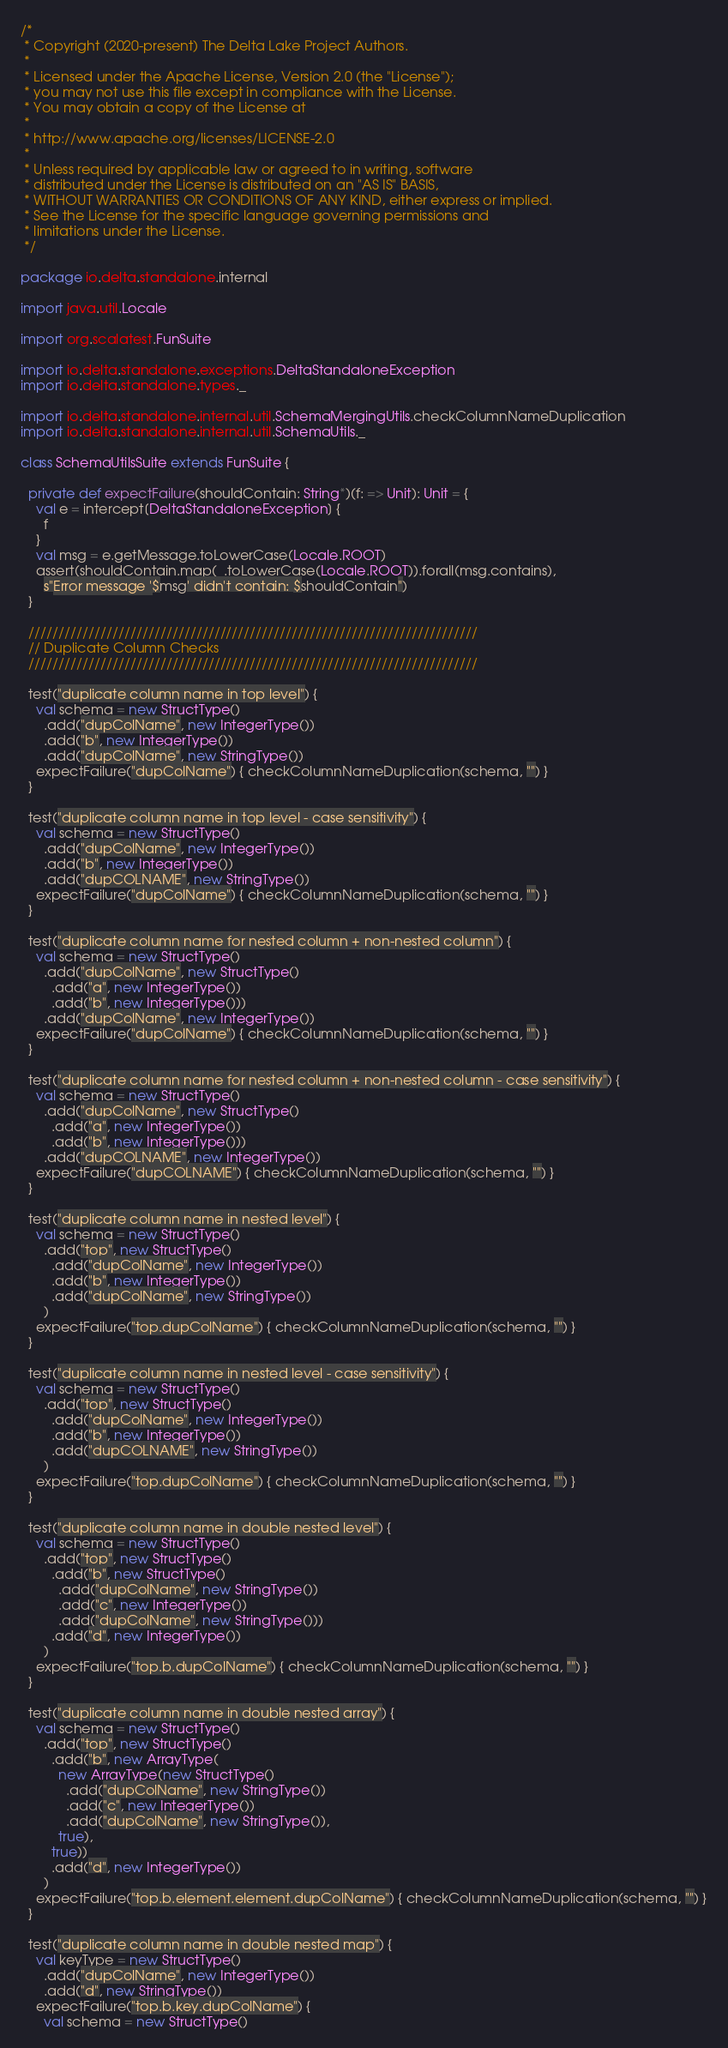<code> <loc_0><loc_0><loc_500><loc_500><_Scala_>/*
 * Copyright (2020-present) The Delta Lake Project Authors.
 *
 * Licensed under the Apache License, Version 2.0 (the "License");
 * you may not use this file except in compliance with the License.
 * You may obtain a copy of the License at
 *
 * http://www.apache.org/licenses/LICENSE-2.0
 *
 * Unless required by applicable law or agreed to in writing, software
 * distributed under the License is distributed on an "AS IS" BASIS,
 * WITHOUT WARRANTIES OR CONDITIONS OF ANY KIND, either express or implied.
 * See the License for the specific language governing permissions and
 * limitations under the License.
 */

package io.delta.standalone.internal

import java.util.Locale

import org.scalatest.FunSuite

import io.delta.standalone.exceptions.DeltaStandaloneException
import io.delta.standalone.types._

import io.delta.standalone.internal.util.SchemaMergingUtils.checkColumnNameDuplication
import io.delta.standalone.internal.util.SchemaUtils._

class SchemaUtilsSuite extends FunSuite {

  private def expectFailure(shouldContain: String*)(f: => Unit): Unit = {
    val e = intercept[DeltaStandaloneException] {
      f
    }
    val msg = e.getMessage.toLowerCase(Locale.ROOT)
    assert(shouldContain.map(_.toLowerCase(Locale.ROOT)).forall(msg.contains),
      s"Error message '$msg' didn't contain: $shouldContain")
  }

  ///////////////////////////////////////////////////////////////////////////
  // Duplicate Column Checks
  ///////////////////////////////////////////////////////////////////////////

  test("duplicate column name in top level") {
    val schema = new StructType()
      .add("dupColName", new IntegerType())
      .add("b", new IntegerType())
      .add("dupColName", new StringType())
    expectFailure("dupColName") { checkColumnNameDuplication(schema, "") }
  }

  test("duplicate column name in top level - case sensitivity") {
    val schema = new StructType()
      .add("dupColName", new IntegerType())
      .add("b", new IntegerType())
      .add("dupCOLNAME", new StringType())
    expectFailure("dupColName") { checkColumnNameDuplication(schema, "") }
  }

  test("duplicate column name for nested column + non-nested column") {
    val schema = new StructType()
      .add("dupColName", new StructType()
        .add("a", new IntegerType())
        .add("b", new IntegerType()))
      .add("dupColName", new IntegerType())
    expectFailure("dupColName") { checkColumnNameDuplication(schema, "") }
  }

  test("duplicate column name for nested column + non-nested column - case sensitivity") {
    val schema = new StructType()
      .add("dupColName", new StructType()
        .add("a", new IntegerType())
        .add("b", new IntegerType()))
      .add("dupCOLNAME", new IntegerType())
    expectFailure("dupCOLNAME") { checkColumnNameDuplication(schema, "") }
  }

  test("duplicate column name in nested level") {
    val schema = new StructType()
      .add("top", new StructType()
        .add("dupColName", new IntegerType())
        .add("b", new IntegerType())
        .add("dupColName", new StringType())
      )
    expectFailure("top.dupColName") { checkColumnNameDuplication(schema, "") }
  }

  test("duplicate column name in nested level - case sensitivity") {
    val schema = new StructType()
      .add("top", new StructType()
        .add("dupColName", new IntegerType())
        .add("b", new IntegerType())
        .add("dupCOLNAME", new StringType())
      )
    expectFailure("top.dupColName") { checkColumnNameDuplication(schema, "") }
  }

  test("duplicate column name in double nested level") {
    val schema = new StructType()
      .add("top", new StructType()
        .add("b", new StructType()
          .add("dupColName", new StringType())
          .add("c", new IntegerType())
          .add("dupColName", new StringType()))
        .add("d", new IntegerType())
      )
    expectFailure("top.b.dupColName") { checkColumnNameDuplication(schema, "") }
  }

  test("duplicate column name in double nested array") {
    val schema = new StructType()
      .add("top", new StructType()
        .add("b", new ArrayType(
          new ArrayType(new StructType()
            .add("dupColName", new StringType())
            .add("c", new IntegerType())
            .add("dupColName", new StringType()),
          true),
        true))
        .add("d", new IntegerType())
      )
    expectFailure("top.b.element.element.dupColName") { checkColumnNameDuplication(schema, "") }
  }

  test("duplicate column name in double nested map") {
    val keyType = new StructType()
      .add("dupColName", new IntegerType())
      .add("d", new StringType())
    expectFailure("top.b.key.dupColName") {
      val schema = new StructType()</code> 